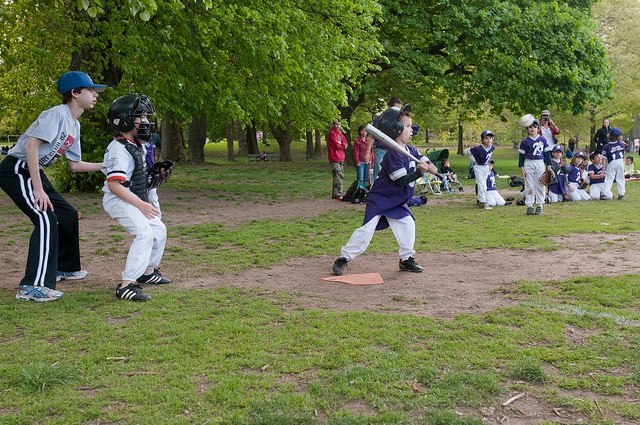Describe the objects in this image and their specific colors. I can see people in darkgreen, black, darkgray, and gray tones, people in darkgreen, black, lavender, gray, and darkgray tones, people in darkgreen, black, navy, lavender, and darkgray tones, people in darkgreen, black, gray, and olive tones, and people in darkgreen, darkgray, lavender, black, and navy tones in this image. 